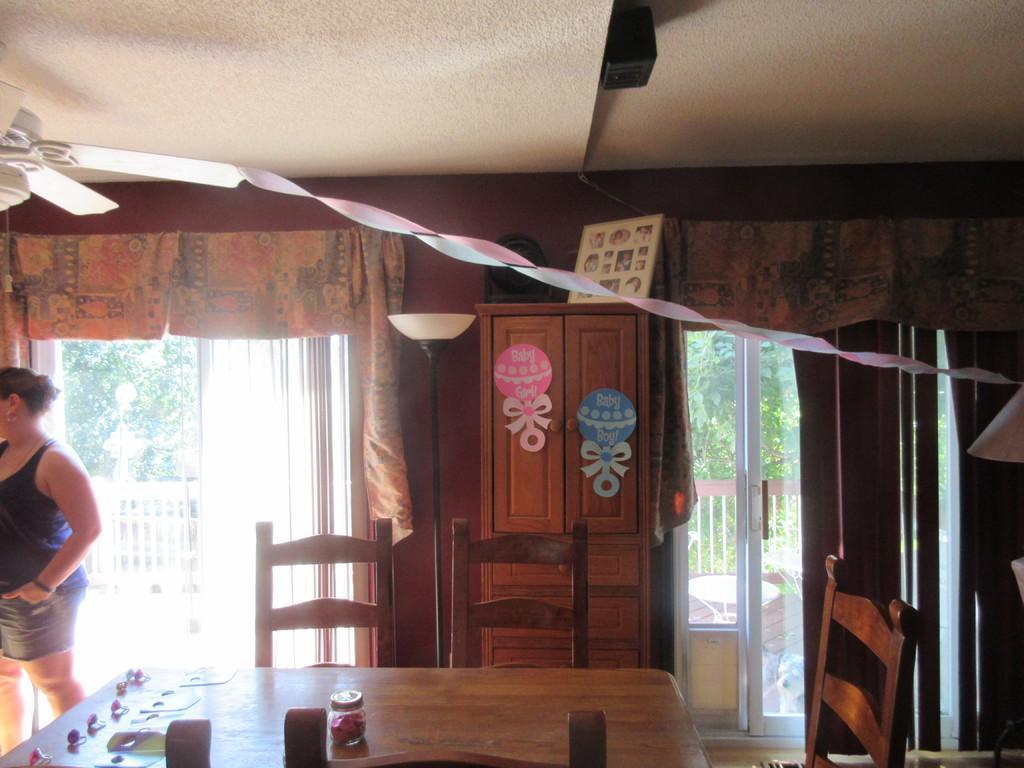How would you summarize this image in a sentence or two? There is a table which has some objects on it and there are chairs around the table and there is a women standing in the left corner. 